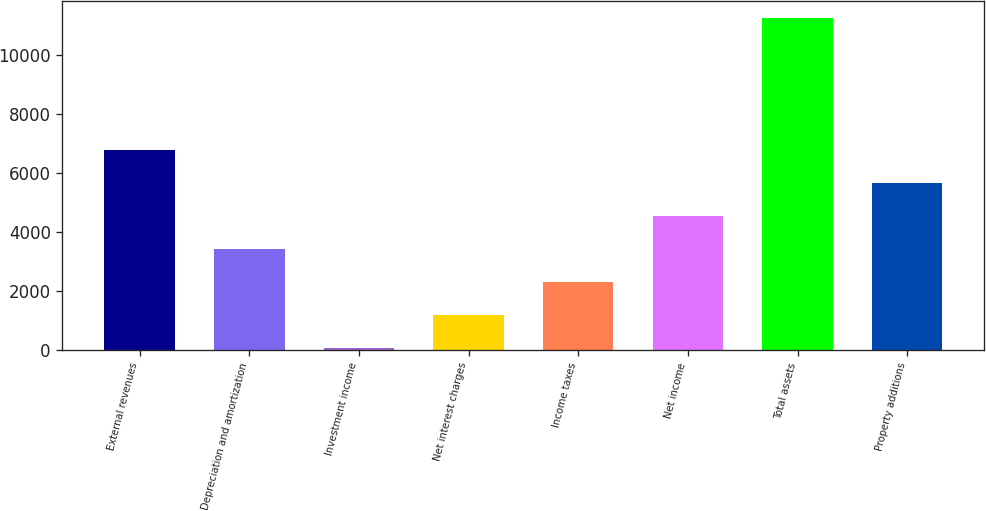Convert chart to OTSL. <chart><loc_0><loc_0><loc_500><loc_500><bar_chart><fcel>External revenues<fcel>Depreciation and amortization<fcel>Investment income<fcel>Net interest charges<fcel>Income taxes<fcel>Net income<fcel>Total assets<fcel>Property additions<nl><fcel>6764.4<fcel>3407.7<fcel>51<fcel>1169.9<fcel>2288.8<fcel>4526.6<fcel>11240<fcel>5645.5<nl></chart> 